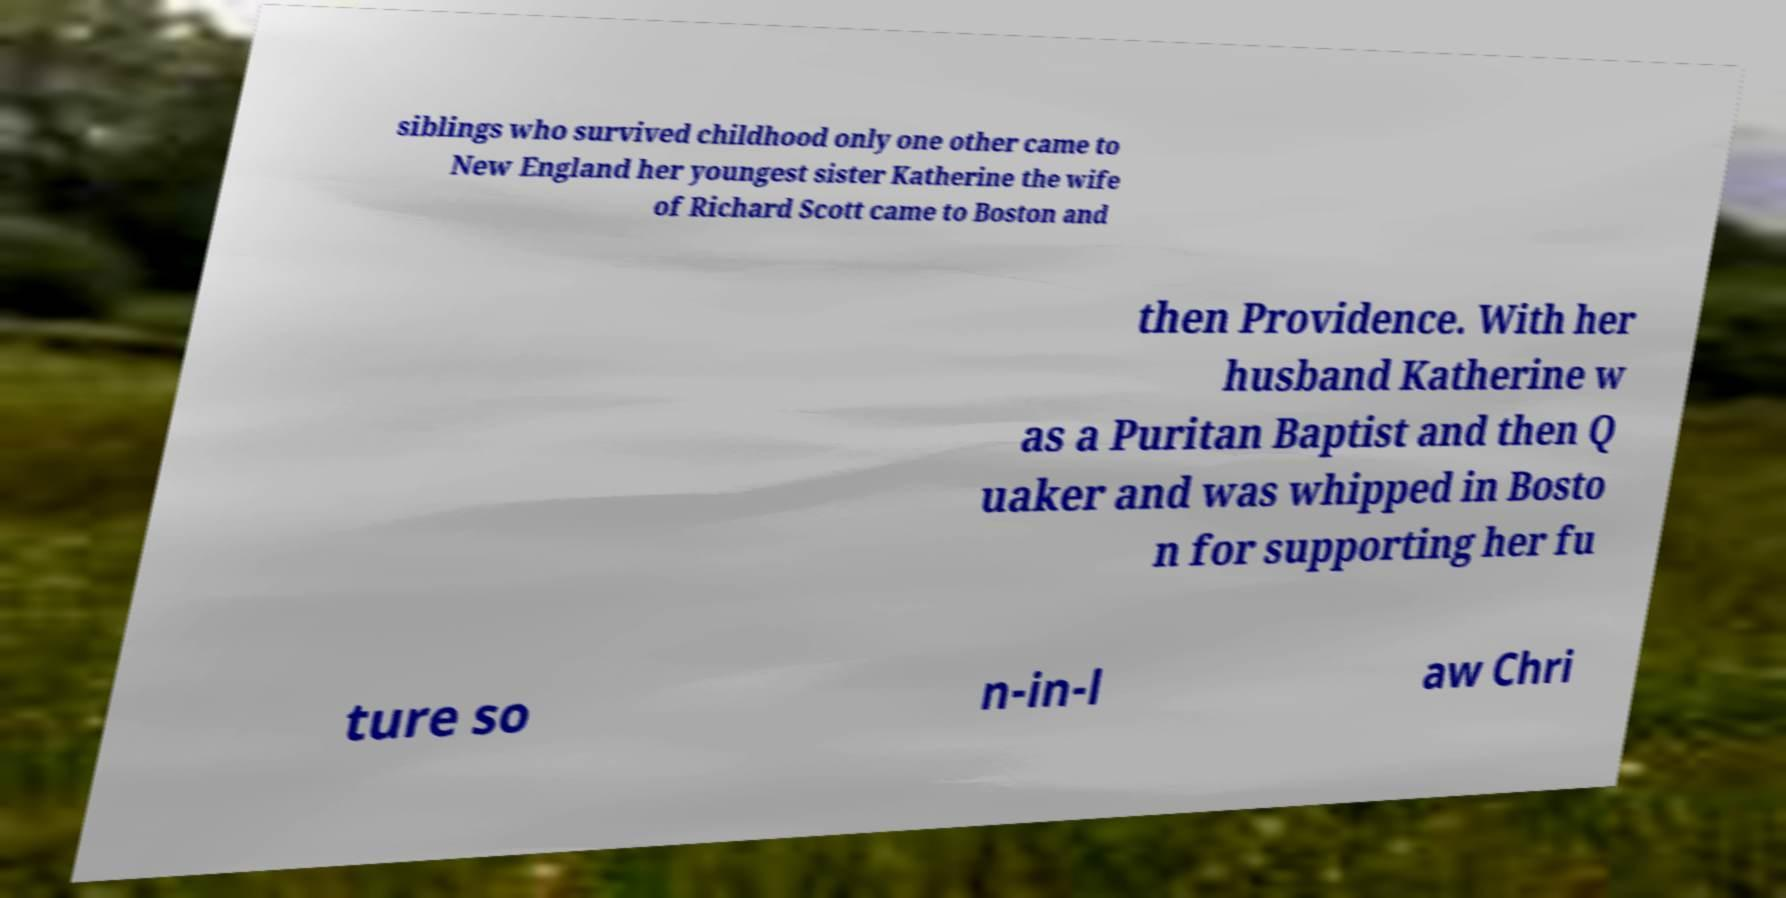Could you assist in decoding the text presented in this image and type it out clearly? siblings who survived childhood only one other came to New England her youngest sister Katherine the wife of Richard Scott came to Boston and then Providence. With her husband Katherine w as a Puritan Baptist and then Q uaker and was whipped in Bosto n for supporting her fu ture so n-in-l aw Chri 